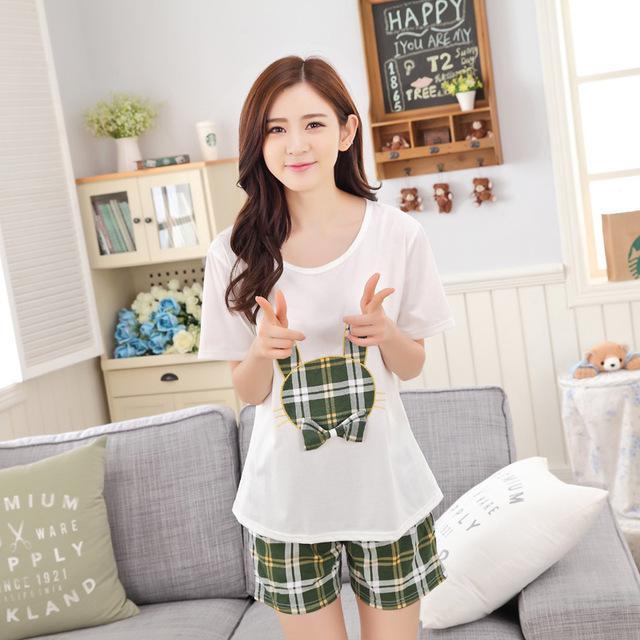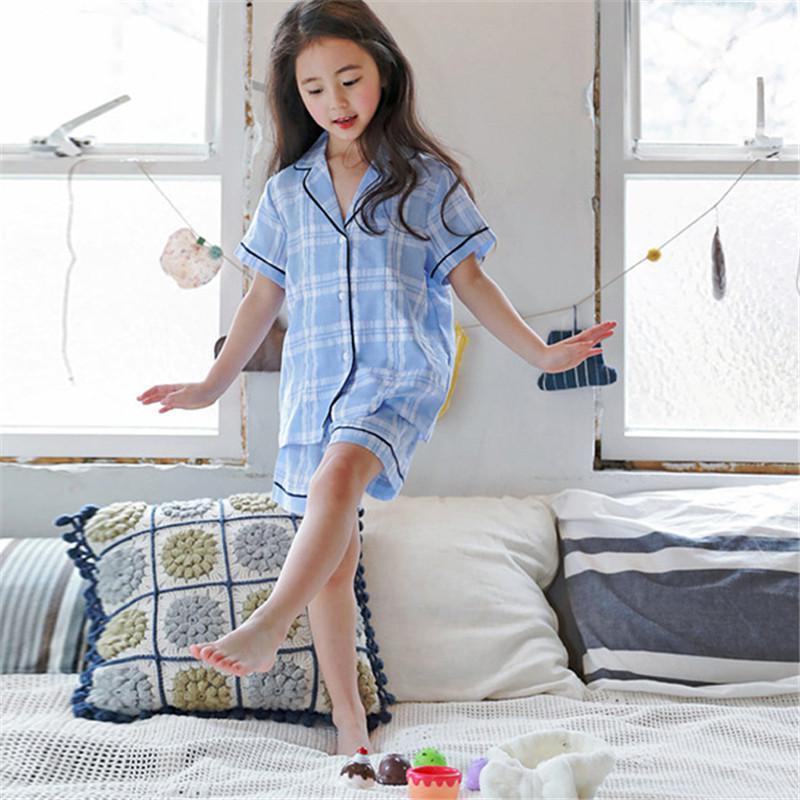The first image is the image on the left, the second image is the image on the right. For the images shown, is this caption "All images include a human model wearing a pajama set featuring plaid bottoms, and one model in matching blue top and bottom is in front of a row of pillows." true? Answer yes or no. Yes. The first image is the image on the left, the second image is the image on the right. For the images displayed, is the sentence "The right image contains one person that is wearing predominately blue sleep wear." factually correct? Answer yes or no. Yes. 